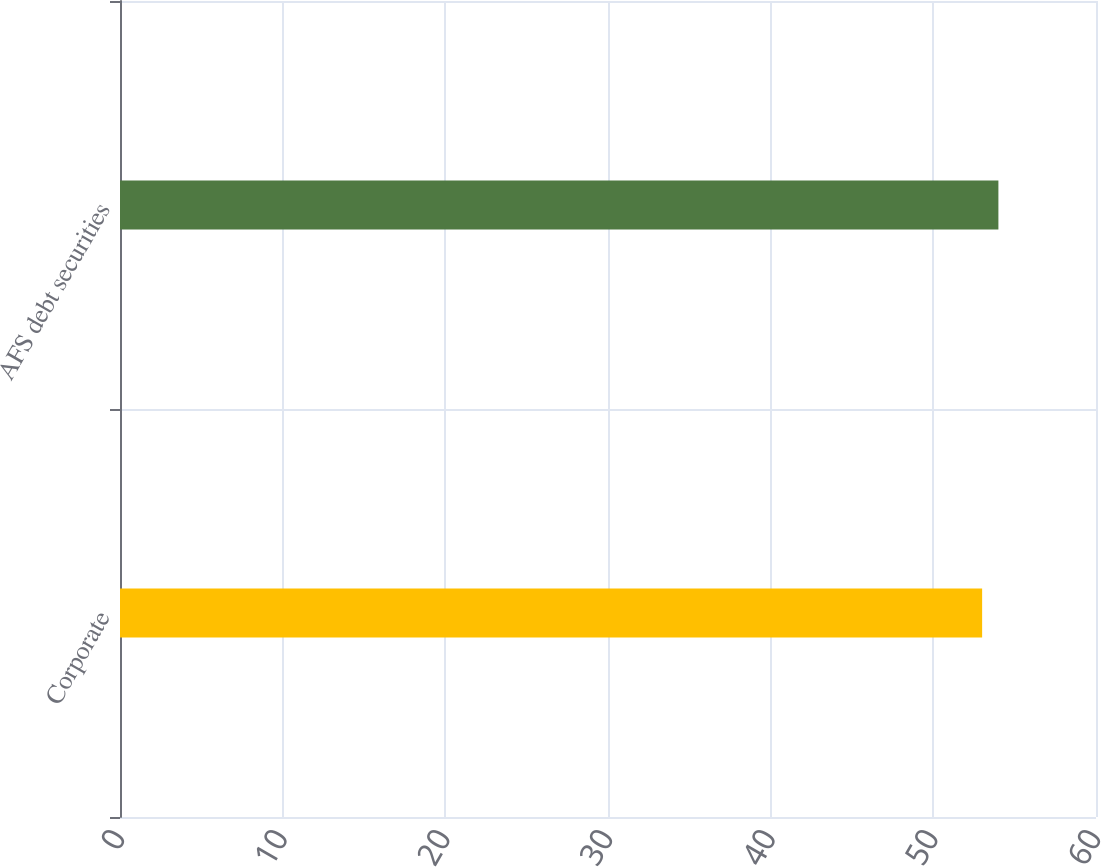Convert chart to OTSL. <chart><loc_0><loc_0><loc_500><loc_500><bar_chart><fcel>Corporate<fcel>AFS debt securities<nl><fcel>53<fcel>54<nl></chart> 